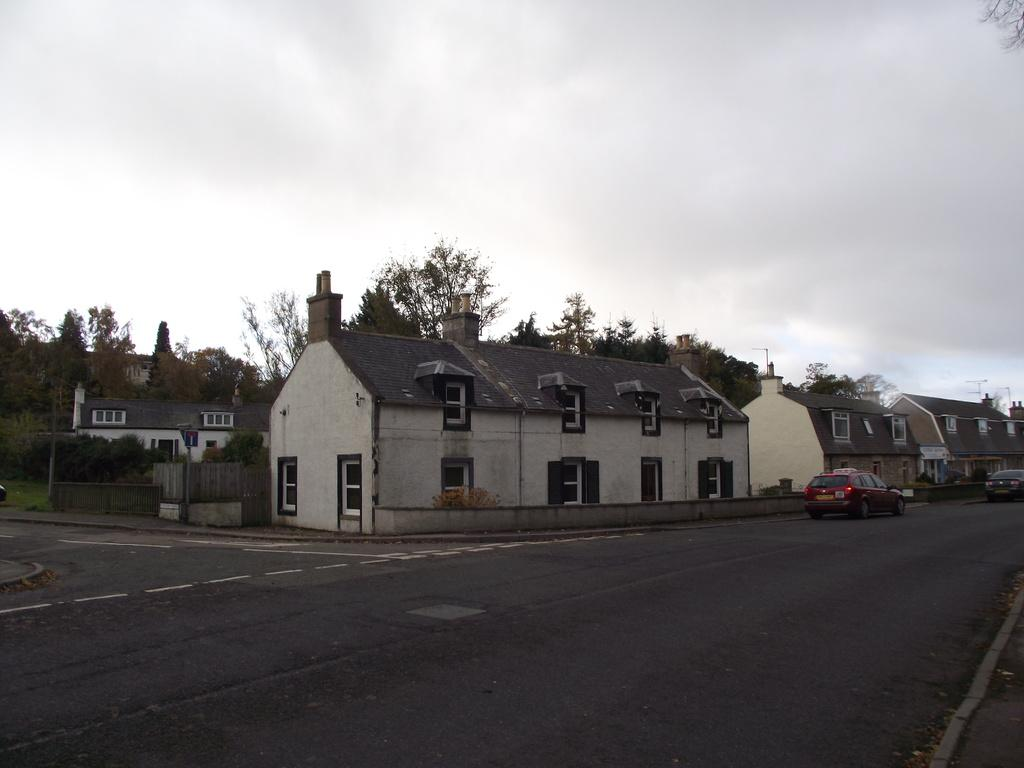What type of structures can be seen in the image? There are buildings in the image. What is happening on the road in the image? Motor vehicles are present on the road in the image. What type of fencing can be seen in the image? Wooden fences are visible in the image. What type of vegetation is present in the image? Trees are present in the image. What is visible in the sky in the image? The sky is visible in the image, and clouds are present in the sky. How many apples are hanging from the trees in the image? There are no apples present in the image; only trees are visible. What type of knee injury can be seen in the image? There is no knee injury present in the image; it features buildings, motor vehicles, wooden fences, trees, and a sky with clouds. 